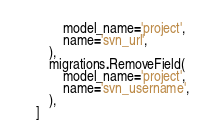<code> <loc_0><loc_0><loc_500><loc_500><_Python_>            model_name='project',
            name='svn_url',
        ),
        migrations.RemoveField(
            model_name='project',
            name='svn_username',
        ),
    ]
</code> 